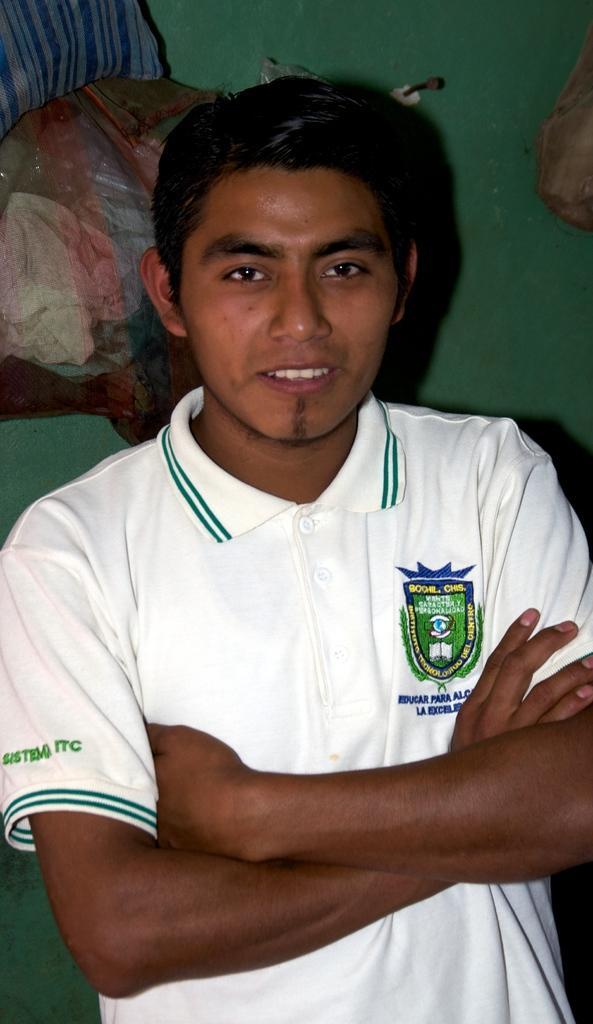Can you describe this image briefly? In this image I can see a person standing and the person is wearing white color shirt and I can see green color background. 